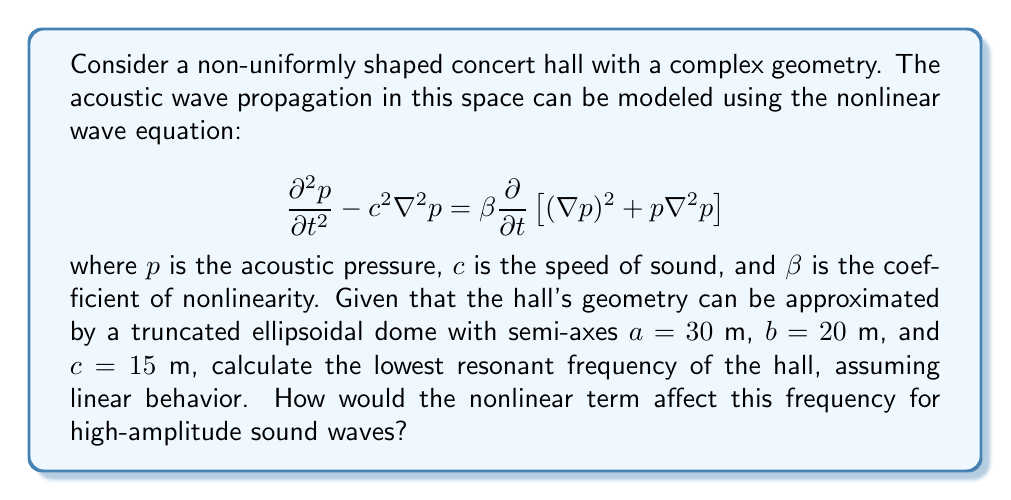Solve this math problem. To solve this problem, we'll follow these steps:

1) First, we need to find the resonant frequencies for a linear approximation of the wave equation in an ellipsoidal domain. The linear wave equation is:

   $$\frac{\partial^2 p}{\partial t^2} - c^2 \nabla^2 p = 0$$

2) The solution for the resonant frequencies in an ellipsoidal cavity is given by:

   $$f_{lmn} = \frac{c}{2\pi} \sqrt{\frac{l^2}{a^2} + \frac{m^2}{b^2} + \frac{n^2}{c^2}}$$

   where $l$, $m$, and $n$ are non-negative integers, and at least two of them are non-zero.

3) The lowest resonant frequency occurs when $l=1$, $m=1$, and $n=0$. Substituting the given values:

   $$f_{110} = \frac{343}{2\pi} \sqrt{\frac{1^2}{30^2} + \frac{1^2}{20^2} + \frac{0^2}{15^2}}$$

4) Calculating this:

   $$f_{110} = 54.6 \text{ Hz} \approx 55 \text{ Hz}$$

5) For the nonlinear case, the term on the right-hand side of the full equation becomes significant for high-amplitude waves:

   $$\beta \frac{\partial}{\partial t}\left[(\nabla p)^2 + p \nabla^2 p\right]$$

6) This nonlinear term introduces harmonic distortion, which means that energy is transferred from the fundamental frequency to higher harmonics. As a result, the effective resonant frequency can shift slightly higher than the linear prediction.

7) The magnitude of this shift depends on the amplitude of the sound waves and the nonlinearity coefficient $\beta$. For typical air at room temperature, $\beta \approx 1.2$.

8) While an exact calculation of the frequency shift requires complex numerical analysis, we can estimate that for high-amplitude waves, the lowest resonant frequency might increase by a few percent compared to the linear prediction.
Answer: Linear lowest resonant frequency: 55 Hz. Nonlinearity causes slight upward shift for high-amplitude waves. 